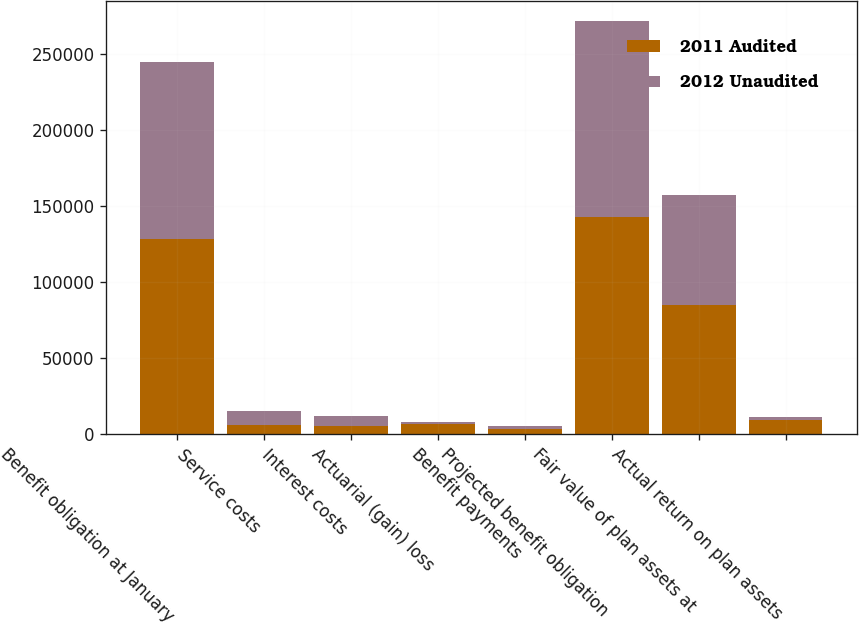Convert chart to OTSL. <chart><loc_0><loc_0><loc_500><loc_500><stacked_bar_chart><ecel><fcel>Benefit obligation at January<fcel>Service costs<fcel>Interest costs<fcel>Actuarial (gain) loss<fcel>Benefit payments<fcel>Projected benefit obligation<fcel>Fair value of plan assets at<fcel>Actual return on plan assets<nl><fcel>2011 Audited<fcel>128567<fcel>5707<fcel>5413<fcel>6560<fcel>3089<fcel>143158<fcel>84751<fcel>9480<nl><fcel>2012 Unaudited<fcel>116572<fcel>9243<fcel>6373<fcel>1403<fcel>2218<fcel>128567<fcel>72400<fcel>1809<nl></chart> 